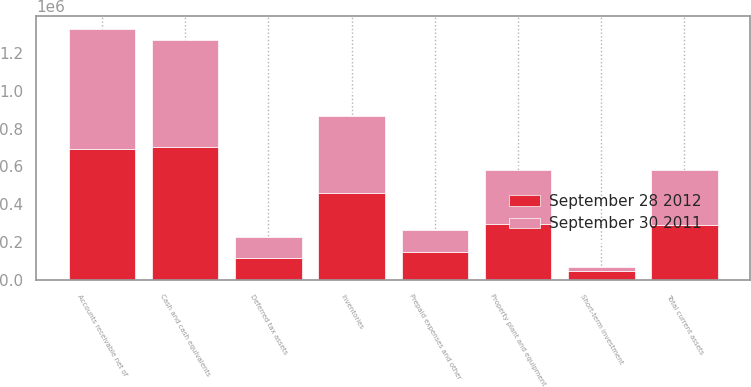Convert chart. <chart><loc_0><loc_0><loc_500><loc_500><stacked_bar_chart><ecel><fcel>Cash and cash equivalents<fcel>Short-term investment<fcel>Accounts receivable net of<fcel>Inventories<fcel>Prepaid expenses and other<fcel>Deferred tax assets<fcel>Total current assets<fcel>Property plant and equipment<nl><fcel>September 28 2012<fcel>704570<fcel>49709<fcel>691806<fcel>457869<fcel>150775<fcel>115786<fcel>291243<fcel>296592<nl><fcel>September 30 2011<fcel>564457<fcel>19205<fcel>635153<fcel>409962<fcel>111875<fcel>113965<fcel>291243<fcel>285894<nl></chart> 